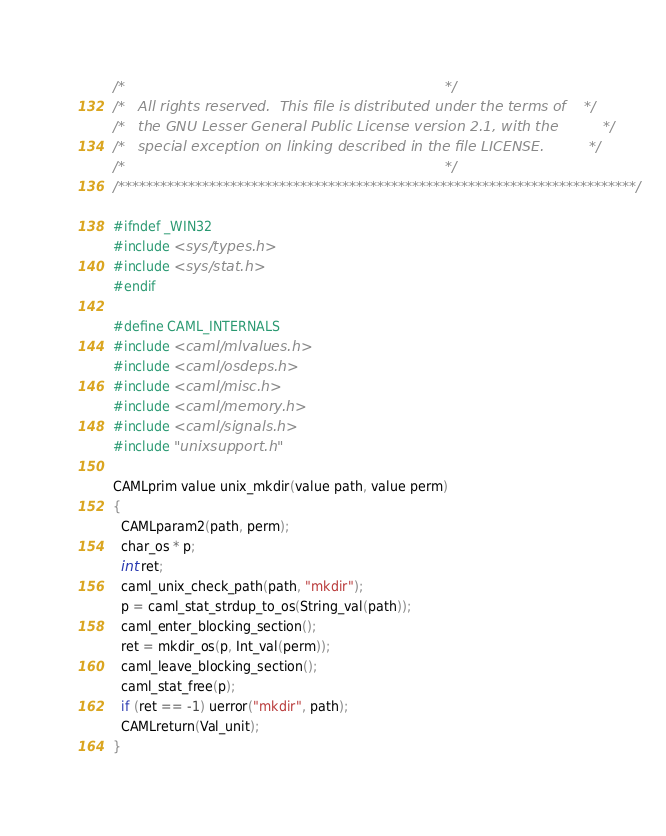<code> <loc_0><loc_0><loc_500><loc_500><_C_>/*                                                                        */
/*   All rights reserved.  This file is distributed under the terms of    */
/*   the GNU Lesser General Public License version 2.1, with the          */
/*   special exception on linking described in the file LICENSE.          */
/*                                                                        */
/**************************************************************************/

#ifndef _WIN32
#include <sys/types.h>
#include <sys/stat.h>
#endif

#define CAML_INTERNALS
#include <caml/mlvalues.h>
#include <caml/osdeps.h>
#include <caml/misc.h>
#include <caml/memory.h>
#include <caml/signals.h>
#include "unixsupport.h"

CAMLprim value unix_mkdir(value path, value perm)
{
  CAMLparam2(path, perm);
  char_os * p;
  int ret;
  caml_unix_check_path(path, "mkdir");
  p = caml_stat_strdup_to_os(String_val(path));
  caml_enter_blocking_section();
  ret = mkdir_os(p, Int_val(perm));
  caml_leave_blocking_section();
  caml_stat_free(p);
  if (ret == -1) uerror("mkdir", path);
  CAMLreturn(Val_unit);
}
</code> 